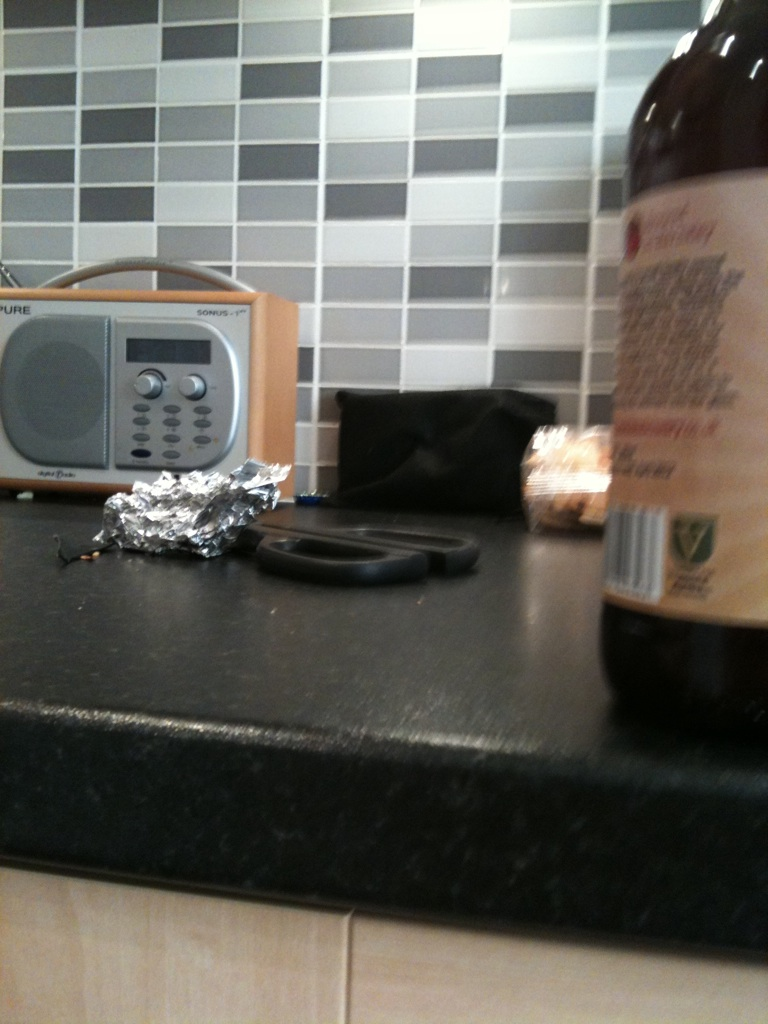Imagine there's a story that includes this kitchen counter in a fantastical world. Please describe it. In a world beyond the ordinary, this kitchen counter exists in a magical realm where every item holds a secret power. The radio isn’t just for playing music—it can summon melodies that mend broken hearts and soothe restless minds. The scissors can cut through not just material objects but also the fabric of reality, creating portals to other dimensions. The aluminum foil acts as a shield, deflecting harmful spells and negative energy. Each morning, as dawn breaks, the kitchen counter awakens, whispering ancient recipes to the cookware that dance to the rhythms emitted by the enchanted radio. This kitchen isn’t merely a place for mundane meals; it’s the heart of a home that pulses with fantastical energy, where everyday tasks like chopping vegetables are part of a grander, mystical ritual that sustains the balance of their magical world. 